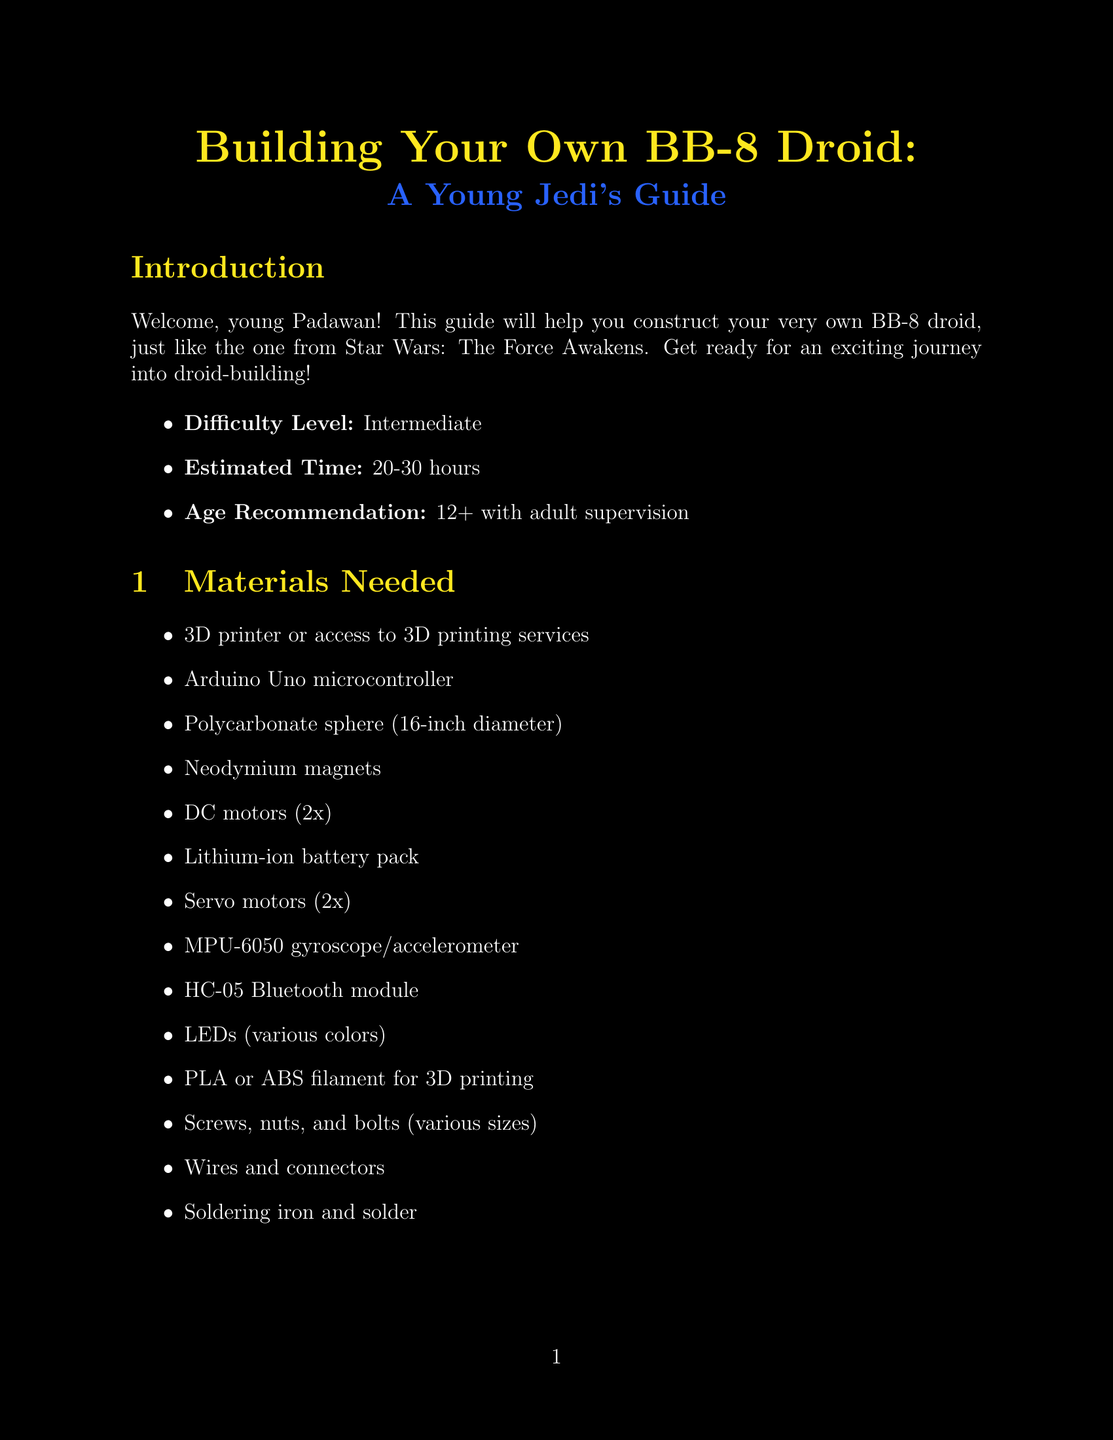what is the estimated time to build the BB-8 droid? The estimated time is listed under the introduction section of the document.
Answer: 20-30 hours what is the age recommendation for building the BB-8 droid? The age recommendation is specified in the introduction section of the document.
Answer: 12+ with adult supervision what type of microcontroller is needed? The document lists the specific materials required for building the droid.
Answer: Arduino Uno microcontroller how many DC motors are required? The document outlines the materials needed, including the quantity of each component.
Answer: 2x what should be done if the BB-8 won't move? The troubleshooting section provides solutions for various problems.
Answer: Check motor connections and battery charge which component is used for Bluetooth communication? The materials needed section includes all electronic components required for the droid.
Answer: HC-05 Bluetooth module what is included in the programming guide key functions? The programming guide details essential programming aspects for the droid.
Answer: Motor control how many assembly steps are there? The assembly steps section indicates the number of distinct actions to construct the BB-8 droid.
Answer: 6 